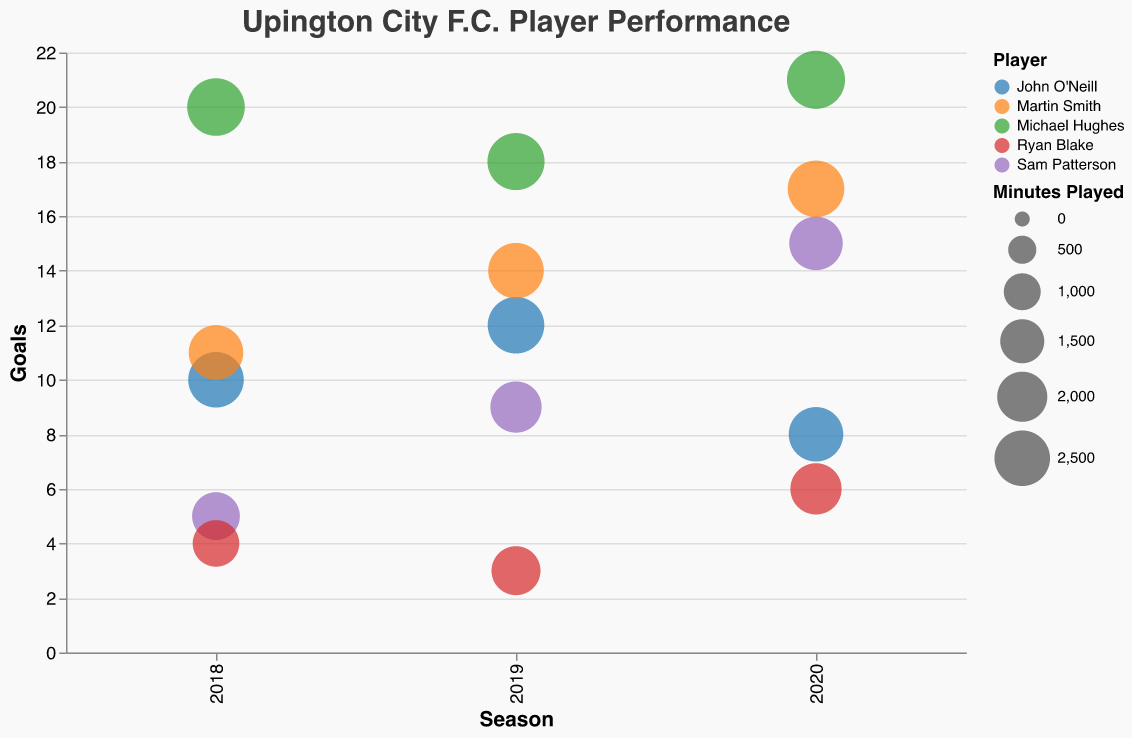How many seasons does the bubble chart visualize for Upington City F.C. players? The x-axis of the bubble chart represents the seasons and shows the tick marks for the years 2018, 2019, 2020. Therefore, three seasons are visualized.
Answer: Three Which player has the largest bubble in the 2020 season? The size of the bubbles represents the minutes played. By looking at the bubbles in the 2020 season, the largest bubble corresponds to Michael Hughes, indicating he played the most minutes.
Answer: Michael Hughes What is the total number of goals scored by John O'Neill in 2019 and 2020 seasons combined? John O'Neill scored 12 goals in 2019 and 8 goals in 2020. Adding these together gives 12 + 8 = 20 goals.
Answer: 20 Between Sam Patterson and Ryan Blake, who had more assists in the 2019 season? Checking the bubble chart for the 2019 season, Sam Patterson had 8 assists, while Ryan Blake had 7 assists. Thus, Sam Patterson had more assists in 2019.
Answer: Sam Patterson Which player had the greatest improvement in goals from 2018 to 2020? To find the greatest improvement, we calculate the difference in goals for each player from 2018 to 2020:
- John O'Neill: 8 - 10 = -2
- Sam Patterson: 15 - 5 = 10
- Michael Hughes: 21 - 20 = 1
- Ryan Blake: 6 - 4 = 2
- Martin Smith: 17 - 11 = 6
Sam Patterson shows the greatest improvement with an increase of 10 goals.
Answer: Sam Patterson Compare the performance of Martin Smith and John O'Neill in terms of assists in 2018. Who had more assists and by how many? In 2018, Martin Smith had 6 assists, while John O'Neill had 8 assists. To find who had more and by how many:
8 (John) - 6 (Martin) = 2
John O'Neill had 2 more assists than Martin Smith.
Answer: John O'Neill by 2 assists What is the average number of minutes played by Michael Hughes over the three seasons? Michael Hughes played 2700, 2650, and 2750 minutes over the three seasons. To find the average:
(2700 + 2650 + 2750) / 3 = 2700
The average is 2700 minutes.
Answer: 2700 Which player had the smallest bubble in 2018, and how many minutes did they play? The size of the bubbles represents the minutes played. The smallest bubble in 2018 belongs to Ryan Blake, who played 1700 minutes.
Answer: Ryan Blake, 1700 minutes 